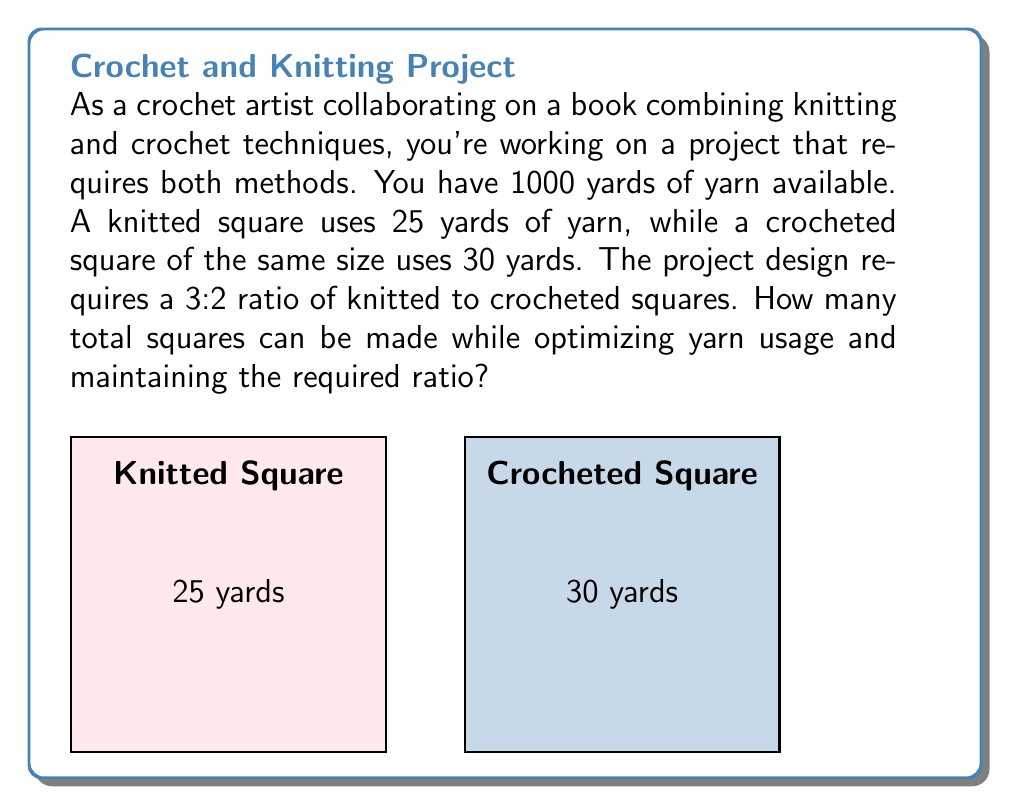Give your solution to this math problem. Let's approach this step-by-step:

1) Let $x$ be the number of knitted squares and $y$ be the number of crocheted squares.

2) Given the 3:2 ratio requirement, we can express this as an equation:
   $$\frac{x}{y} = \frac{3}{2}$$ or $$x = \frac{3}{2}y$$

3) Now, let's set up the optimization equation based on yarn usage:
   $$25x + 30y \leq 1000$$

4) Substituting $x = \frac{3}{2}y$ into this equation:
   $$25(\frac{3}{2}y) + 30y \leq 1000$$
   $$37.5y + 30y \leq 1000$$
   $$67.5y \leq 1000$$

5) Solving for $y$:
   $$y \leq \frac{1000}{67.5} \approx 14.81$$

6) Since we can't have fractional squares, we round down to 14 crocheted squares.

7) If $y = 14$, then $x = \frac{3}{2}(14) = 21$ knitted squares.

8) Total squares = 21 + 14 = 35

9) Let's verify the yarn usage:
   $$(21 * 25) + (14 * 30) = 525 + 420 = 945$$ yards, which is within our 1000 yard limit.

Therefore, we can make 35 total squares while optimizing yarn usage and maintaining the required ratio.
Answer: 35 squares 